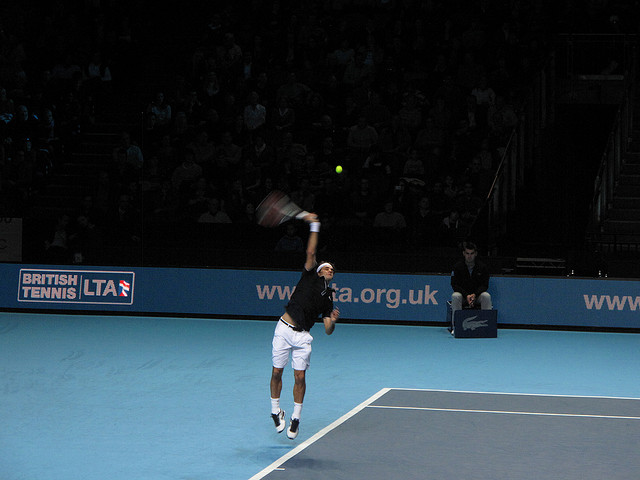<image>What city is this taking place in? I am not sure which city this is taking place in. It could be London. Is HyundaiCard one of the sponsors of this match? I am not sure if HyundaiCard is one of the sponsors of this match. According to the data, HyundaiCard seems not to be a sponsor. What city is this taking place in? I am not sure what city this is taking place in. But it seems to be London. Is HyundaiCard one of the sponsors of this match? I don't know if HyundaiCard is one of the sponsors of this match. It can be both yes or no. 